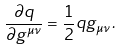<formula> <loc_0><loc_0><loc_500><loc_500>\frac { \partial q } { \partial g ^ { \mu \nu } } = \frac { 1 } { 2 } q g _ { \mu \nu } \, .</formula> 